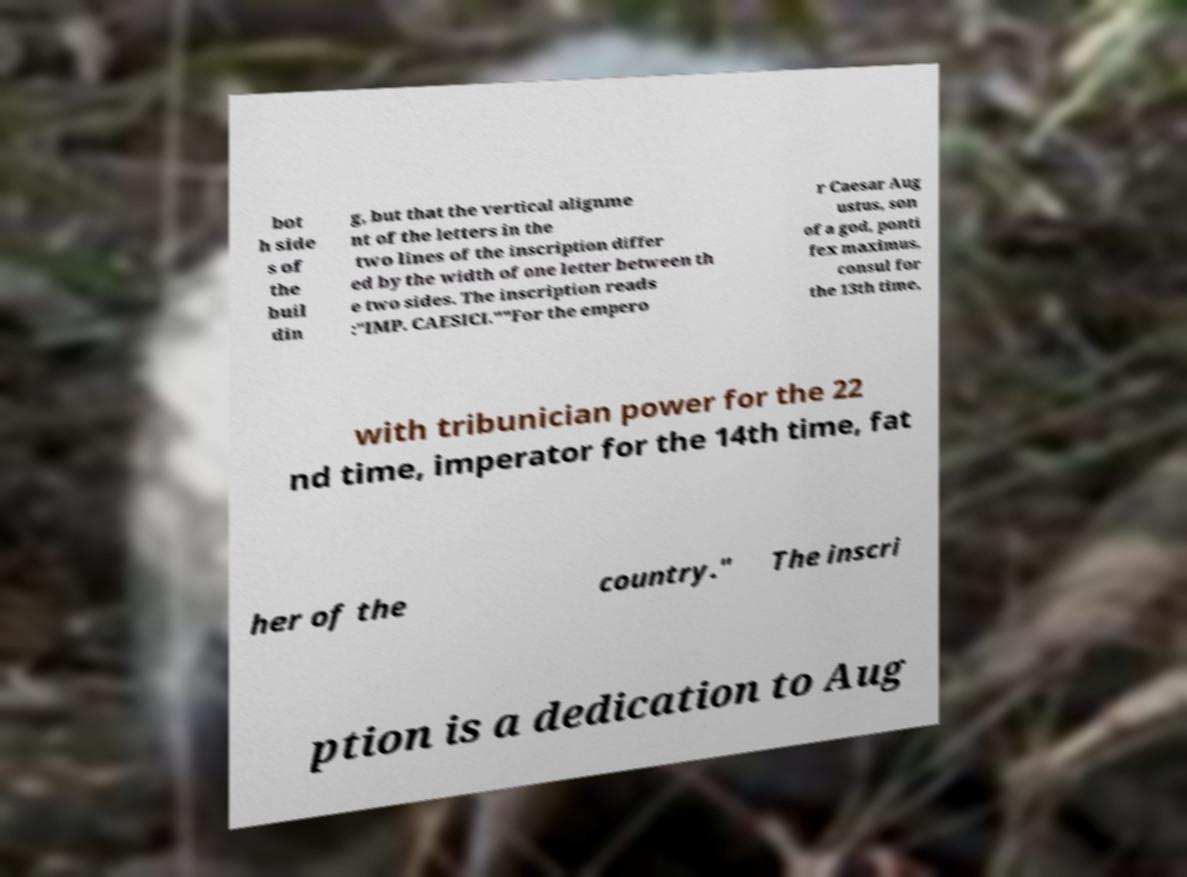What messages or text are displayed in this image? I need them in a readable, typed format. bot h side s of the buil din g, but that the vertical alignme nt of the letters in the two lines of the inscription differ ed by the width of one letter between th e two sides. The inscription reads :"IMP. CAESICI.""For the empero r Caesar Aug ustus, son of a god, ponti fex maximus, consul for the 13th time, with tribunician power for the 22 nd time, imperator for the 14th time, fat her of the country." The inscri ption is a dedication to Aug 